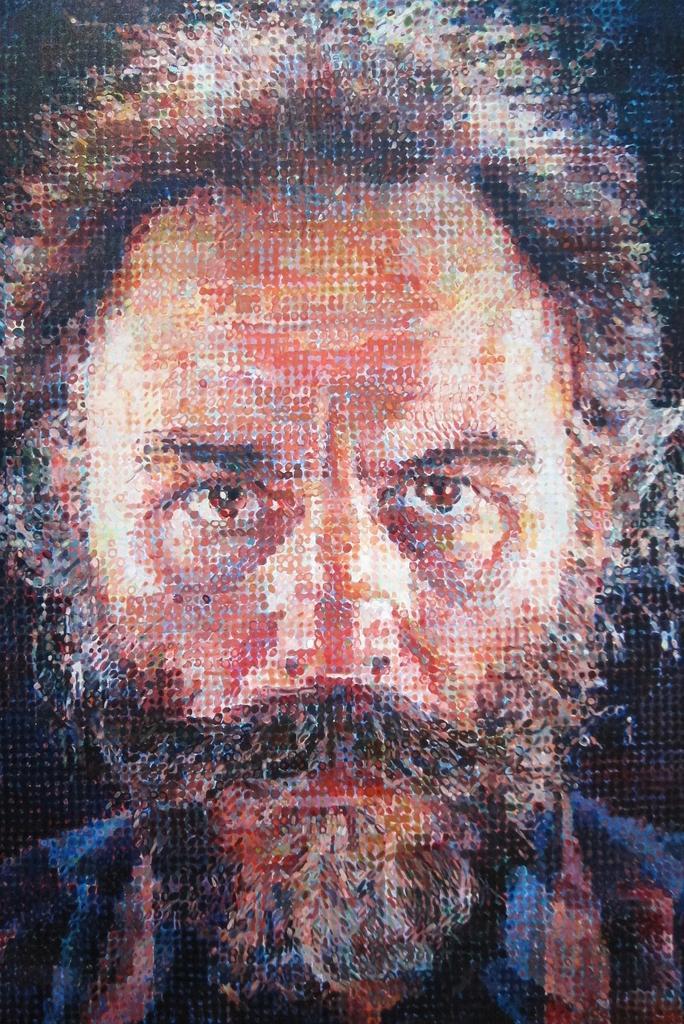How would you summarize this image in a sentence or two? In this picture we can see the edited image of the man standing in the front and looking to the camera. 